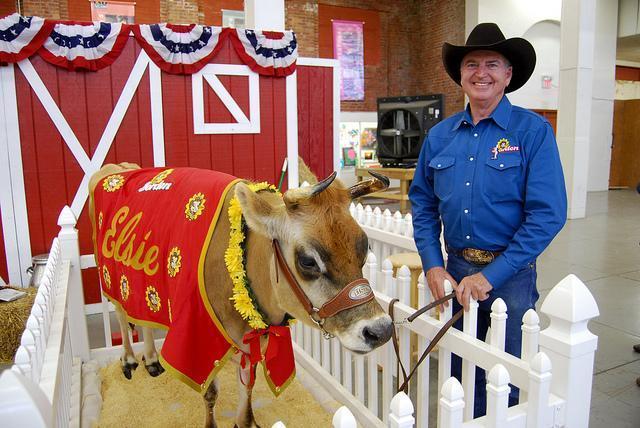Is "The dining table is far away from the cow." an appropriate description for the image?
Answer yes or no. Yes. 